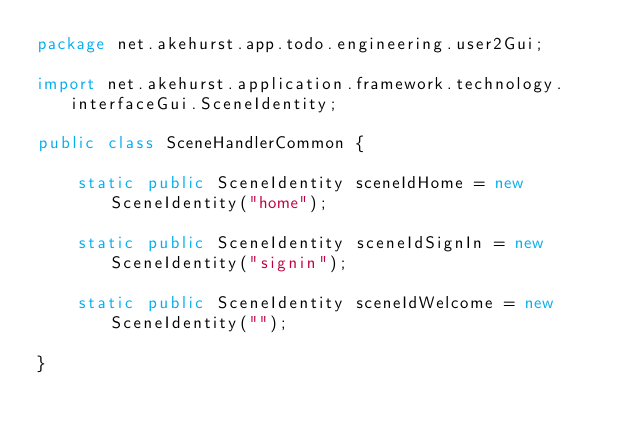Convert code to text. <code><loc_0><loc_0><loc_500><loc_500><_Java_>package net.akehurst.app.todo.engineering.user2Gui;

import net.akehurst.application.framework.technology.interfaceGui.SceneIdentity;

public class SceneHandlerCommon {

	static public SceneIdentity sceneIdHome = new SceneIdentity("home");

	static public SceneIdentity sceneIdSignIn = new SceneIdentity("signin");

	static public SceneIdentity sceneIdWelcome = new SceneIdentity("");

}
</code> 